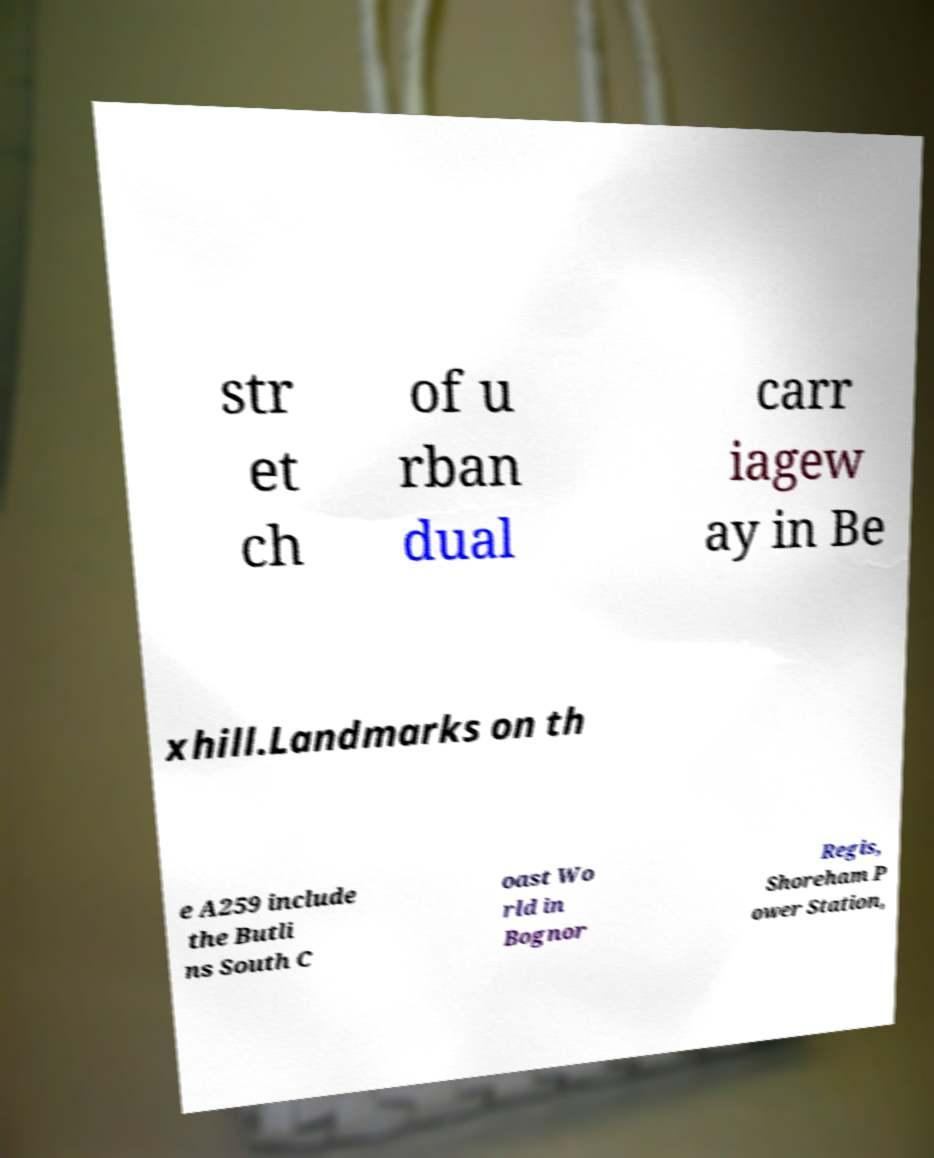Please identify and transcribe the text found in this image. str et ch of u rban dual carr iagew ay in Be xhill.Landmarks on th e A259 include the Butli ns South C oast Wo rld in Bognor Regis, Shoreham P ower Station, 